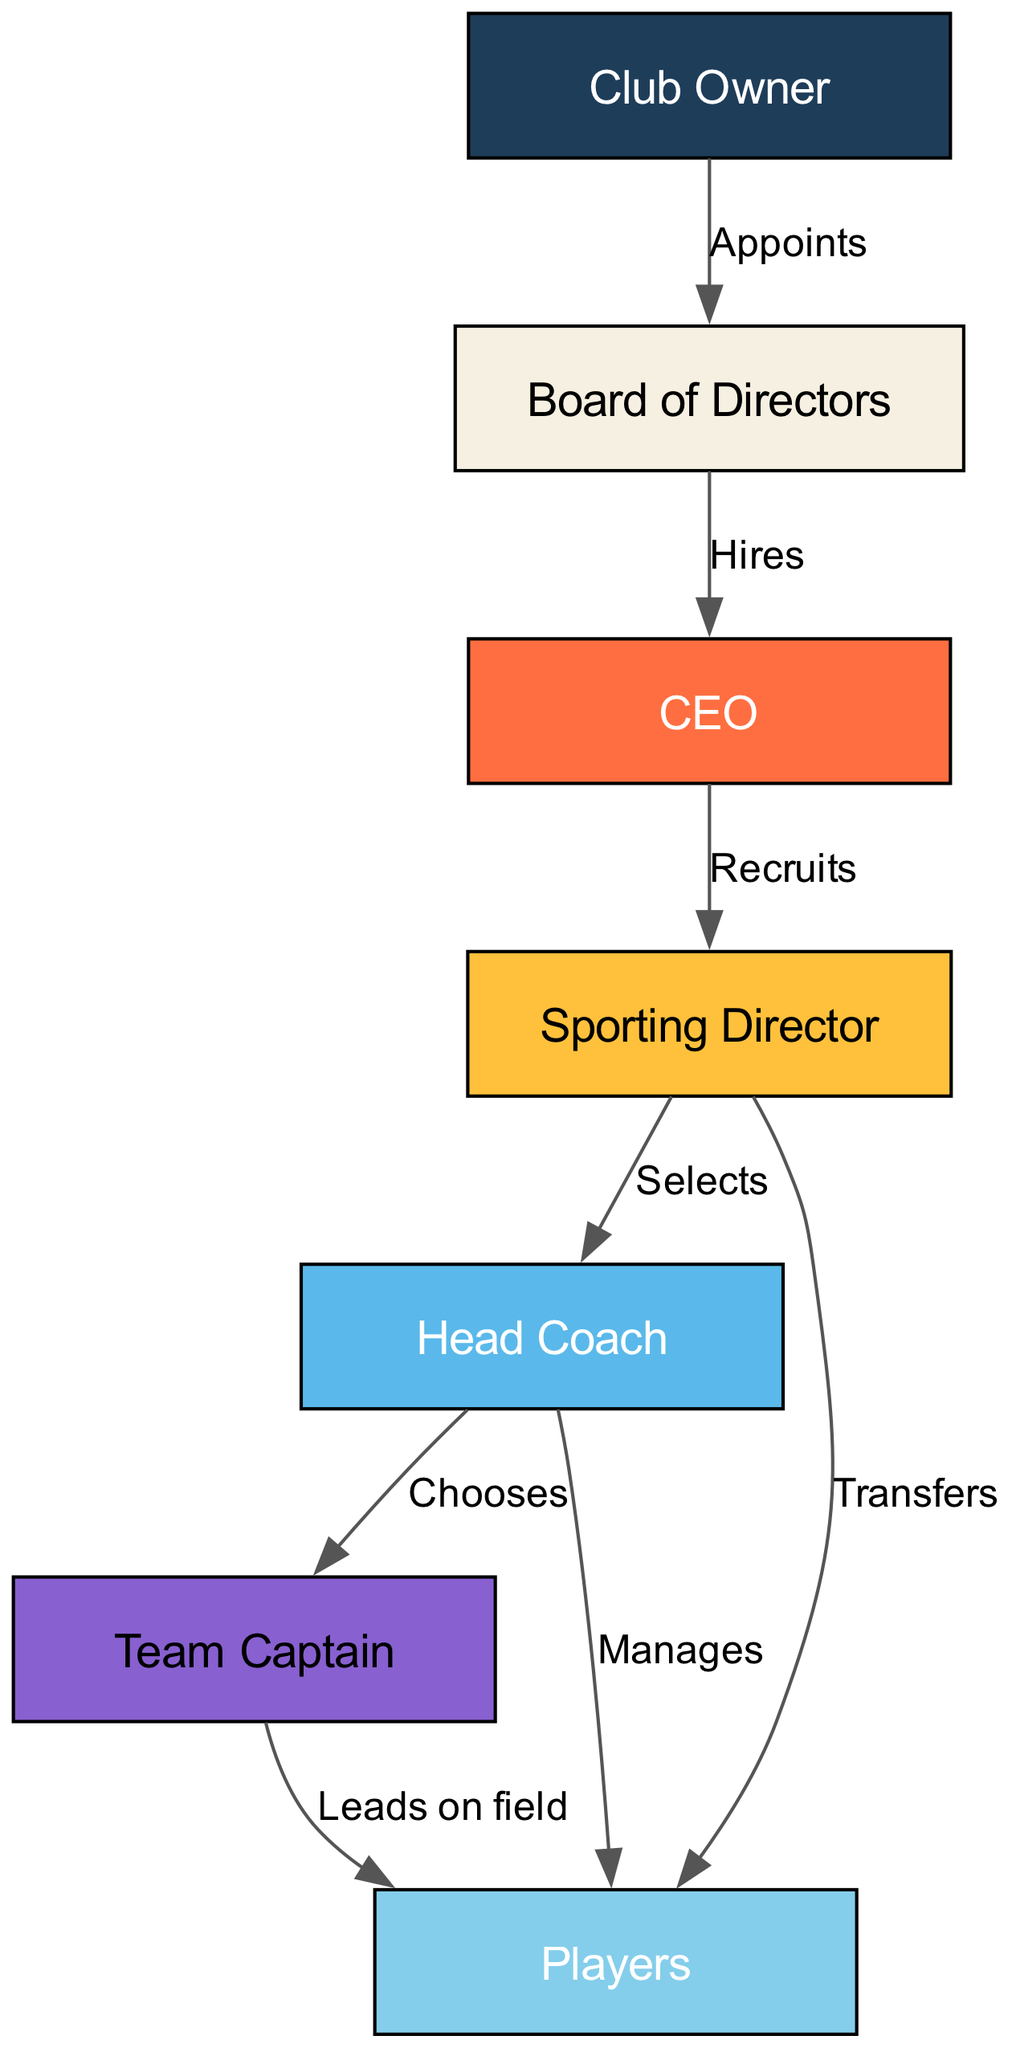What node does the Board of Directors connect to? According to the diagram, the edge labeled "Hires" goes from the "Board of Directors" to the "CEO." Therefore, the Board of Directors connects to the CEO.
Answer: CEO Who appoints the Board of Directors? The diagram indicates that the "Club Owner" has an edge labeled "Appoints" directed to the "Board of Directors." Thus, the Club Owner appoints the Board of Directors.
Answer: Club Owner How many relationships are indicated in the diagram? By counting the edges in the diagram, there are a total of 8 connections that represent the various relationships between the nodes.
Answer: 8 What is the role of the Head Coach in relation to Players? The diagram has an edge showing that the "Head Coach" manages the "Players." This implies that the Head Coach is responsible for overseeing the Players.
Answer: Manages Which node is directly connected to both Sporting Director and Team Captain? The "Players" node has edges connecting to both "Sporting Director" (transfers) and "Team Captain" (leads on field), indicating that Players are directly connected to both.
Answer: Players What is the decision-making order starting from the Club Owner? The diagram shows a flow starting from the "Club Owner," who appoints the "Board of Directors," which hires the "CEO," who recruits the "Sporting Director," who selects the "Head Coach," who chooses the "Team Captain" and manages the "Players." Thus, the order can be outlined as Club Owner → Board of Directors → CEO → Sporting Director → Head Coach → Team Captain → Players.
Answer: Club Owner → Board of Directors → CEO → Sporting Director → Head Coach → Team Captain → Players Who chooses the Team Captain? According to the diagram, the "Head Coach" has a labeled edge "Chooses" directed to the "Team Captain." Therefore, the Head Coach is the one who chooses the Team Captain.
Answer: Head Coach Which node does the Sporting Director transfer players to? The relationship depicted in the diagram shows that the "Sporting Director" has a directed edge labeled "Transfers" leading to the "Players," indicating that the Sporting Director transfers players to the Players node.
Answer: Players How many nodes are represented in this diagram? The diagram lists a total of 7 distinct nodes, which represent the various roles within the football club hierarchy.
Answer: 7 